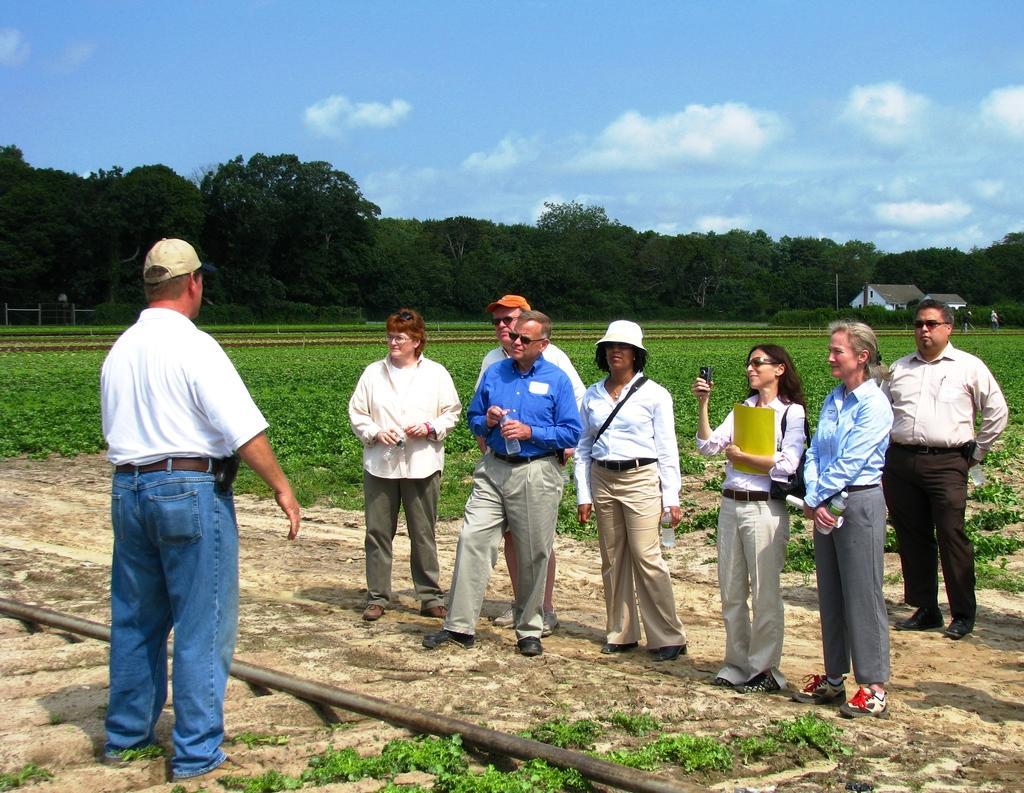Can you describe this image briefly? In the image we can see there are many people standing, wearing clothes, shoes and some of them are wearing a cap and goggles. There are many trees around and we can even see building, grass and cloudy pale blue sky. 